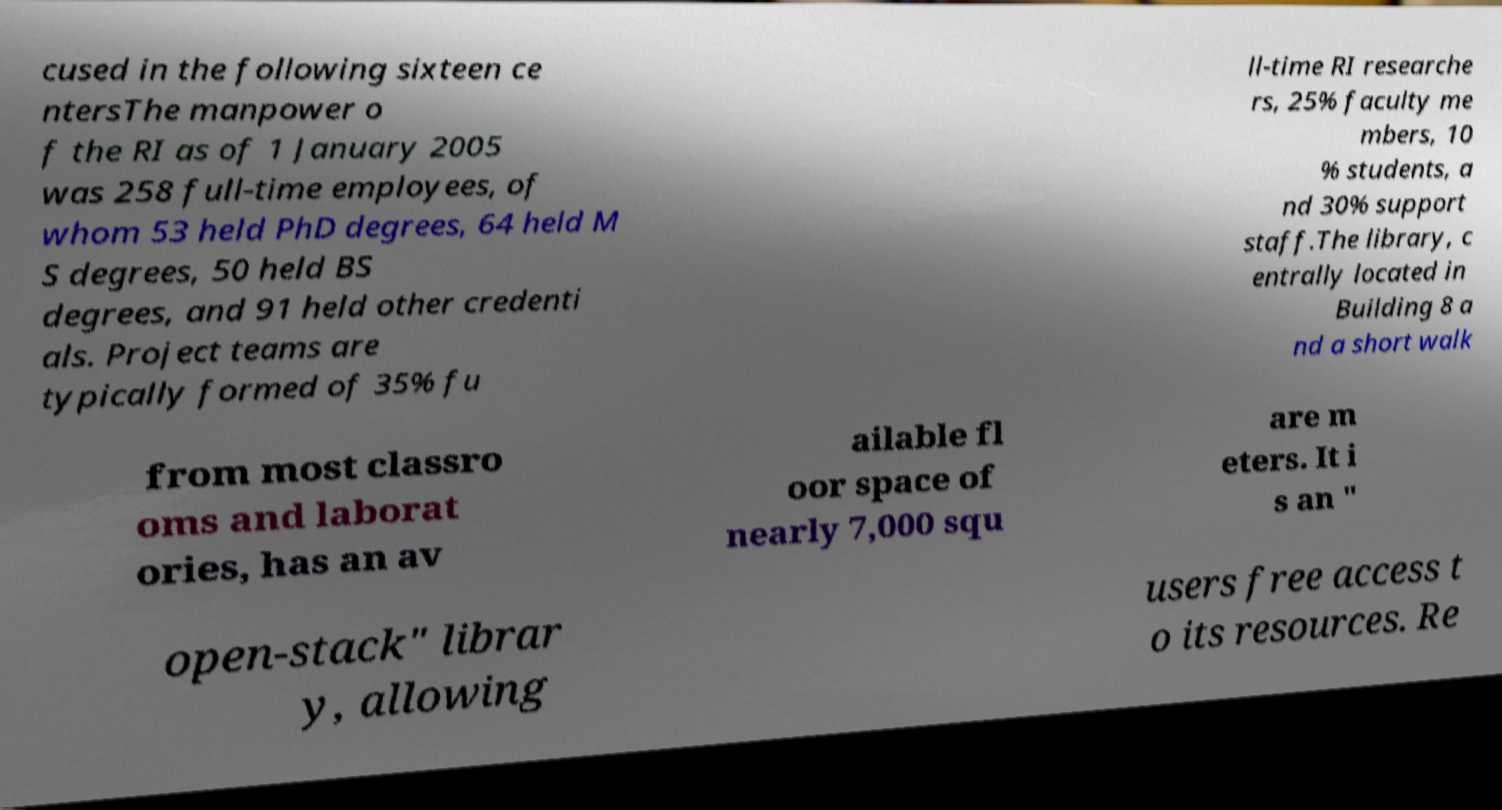Please read and relay the text visible in this image. What does it say? cused in the following sixteen ce ntersThe manpower o f the RI as of 1 January 2005 was 258 full-time employees, of whom 53 held PhD degrees, 64 held M S degrees, 50 held BS degrees, and 91 held other credenti als. Project teams are typically formed of 35% fu ll-time RI researche rs, 25% faculty me mbers, 10 % students, a nd 30% support staff.The library, c entrally located in Building 8 a nd a short walk from most classro oms and laborat ories, has an av ailable fl oor space of nearly 7,000 squ are m eters. It i s an " open-stack" librar y, allowing users free access t o its resources. Re 